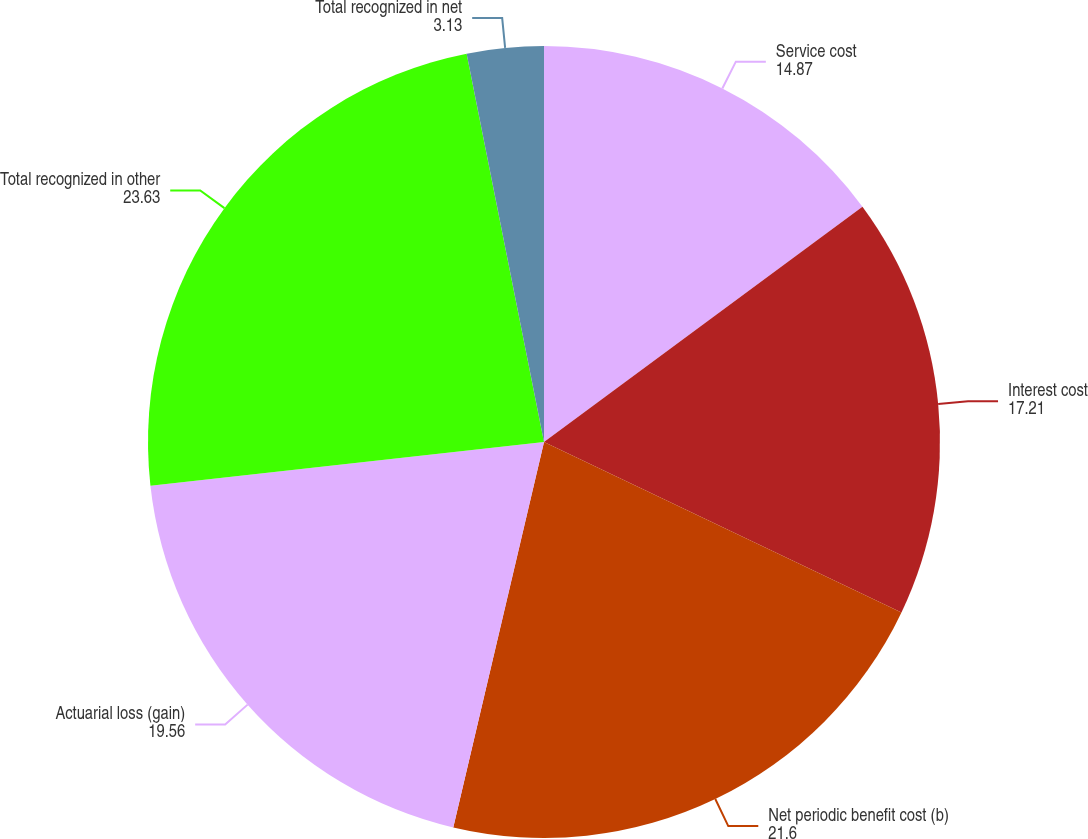<chart> <loc_0><loc_0><loc_500><loc_500><pie_chart><fcel>Service cost<fcel>Interest cost<fcel>Net periodic benefit cost (b)<fcel>Actuarial loss (gain)<fcel>Total recognized in other<fcel>Total recognized in net<nl><fcel>14.87%<fcel>17.21%<fcel>21.6%<fcel>19.56%<fcel>23.63%<fcel>3.13%<nl></chart> 